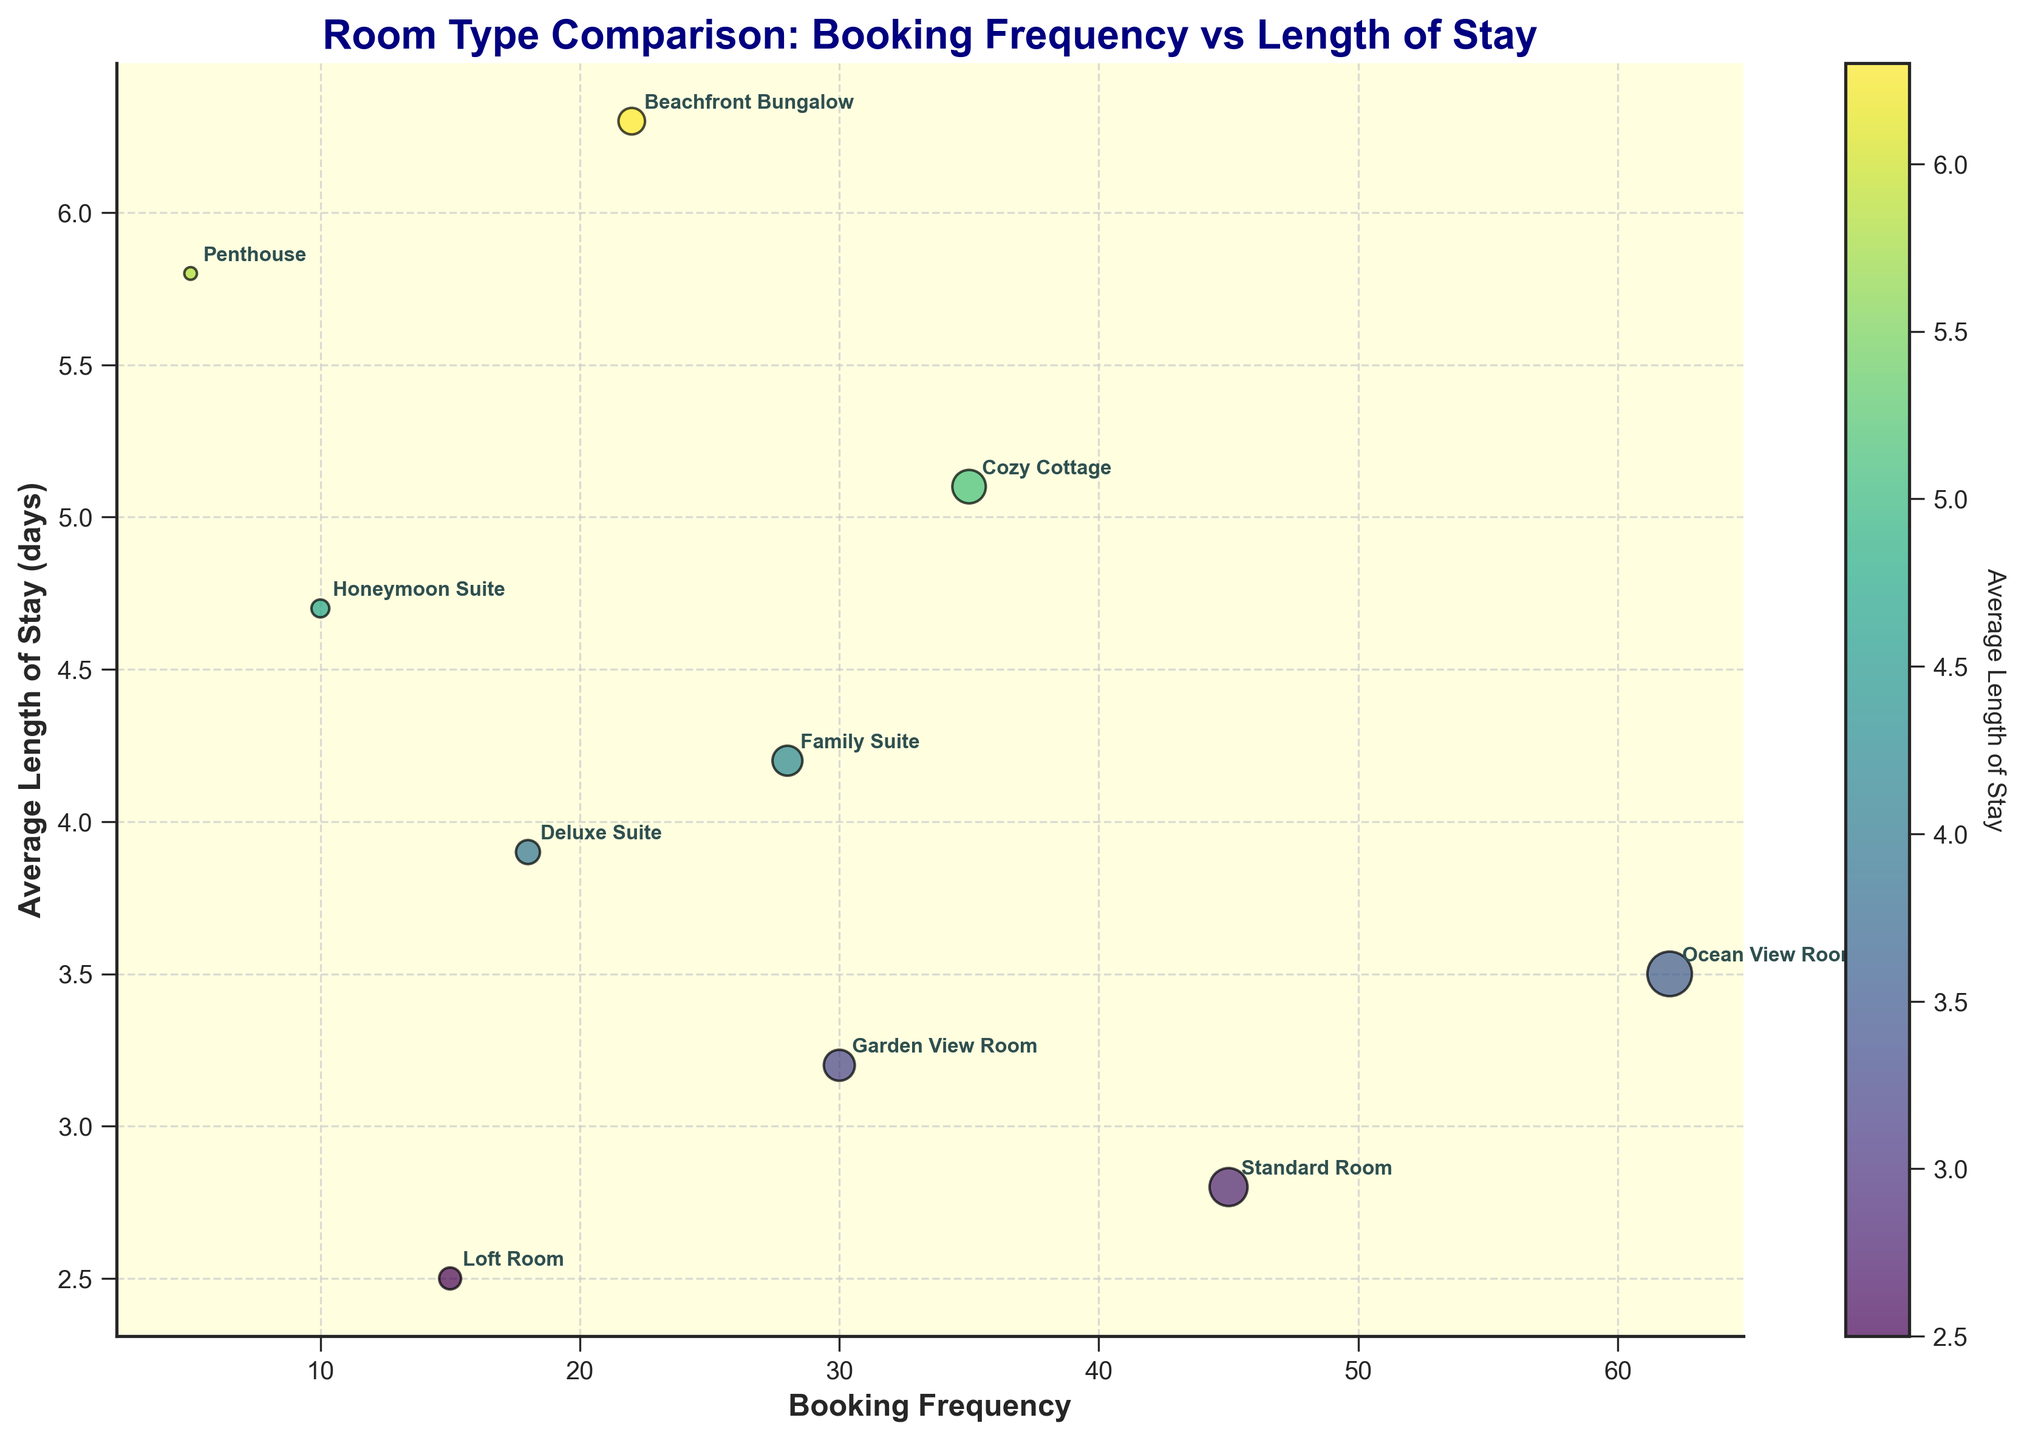What's the title of the figure? The title of the figure is displayed at the top in a larger font size and bold text, reading "Room Type Comparison: Booking Frequency vs Length of Stay".
Answer: Room Type Comparison: Booking Frequency vs Length of Stay Which room type has the highest booking frequency? By observing the horizontal axis and identifying the furthest right point, the "Ocean View Room" has the highest booking frequency.
Answer: Ocean View Room Which room type has the longest average length of stay? By observing the vertical axis and identifying the highest point, the "Beachfront Bungalow" has the longest average length of stay.
Answer: Beachfront Bungalow Compare the booking frequency and average length of stay of the Standard Room and Cozy Cottage. Which room has a higher booking frequency? The Standard Room has a booking frequency of 45, whereas Cozy Cottage has 35. Booking Frequency is measured along the horizontal axis. Hence, Standard Room has a higher booking frequency.
Answer: Standard Room Which room types have an average length of stay greater than 5 days? Points above the 5-day mark on the vertical axis include "Cozy Cottage", "Beachfront Bungalow", and "Penthouse".
Answer: Cozy Cottage, Beachfront Bungalow, Penthouse Which room types have both below-average booking frequency and below-average length of stay? First, note that average booking frequency and average length of stay must be calculated. Then, rooms falling in the bottom-left quadrant of the plot are identified.
Answer: Loft Room, Deluxe Suite, Honeymoon Suite, Penthouse What is the total booking frequency of the rooms with an average length of stay above 5 days? Identify rooms with above 5 days average length of stay and sum their booking frequencies: Cozy Cottage (35) + Beachfront Bungalow (22) + Penthouse (5). 35 + 22 + 5 = 62.
Answer: 62 What is the most common average length of stay range (e.g., 2-3 days, 3-4 days, etc.) among the room types? Most data points fall within the 3-4 days range. By visually grouping points along the vertical axis in these ranges, a count shows this range has the most points.
Answer: 3-4 days Between Family Suite and Honeymoon Suite, which room type has a higher average length of stay? By observing the vertical axis, the Family Suite has an average length of stay of 4.2, whereas Honeymoon Suite has 4.7. Hence, Honeymoon Suite has a higher average length of stay.
Answer: Honeymoon Suite What is the product of the booking frequency and average length of stay for the Garden View Room? The Garden View Room has a booking frequency of 30 and an average length of stay of 3.2. The product of these values is calculated as 30 * 3.2 = 96.
Answer: 96 